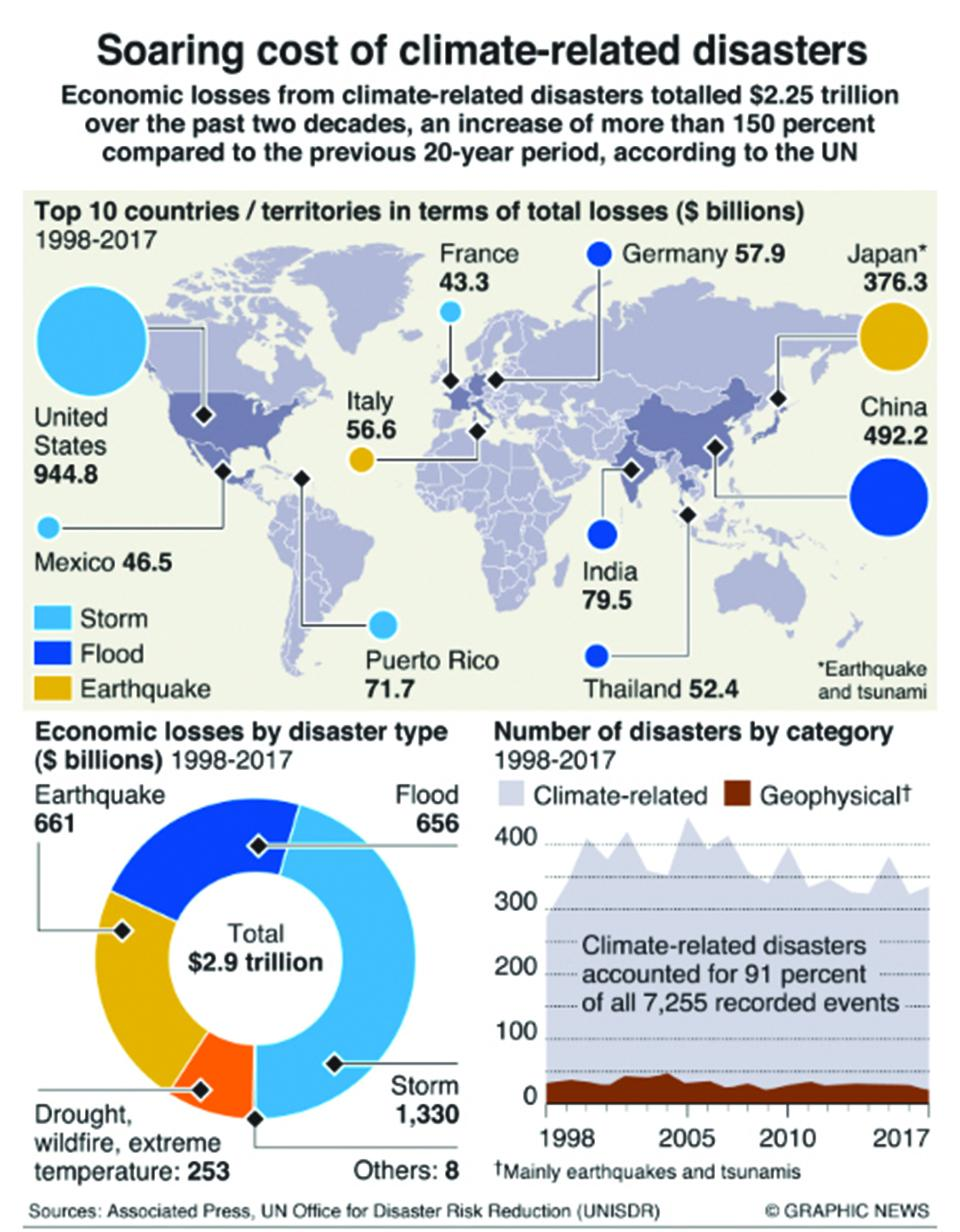Give some essential details in this illustration. The total economic loss caused by the floods between 1998 and 2017 was approximately 656 billion US dollars. Japan has suffered the highest amount of economic loss from earthquakes from 1998 to 2017. According to data compiled from 1998 to 2017, China has suffered the highest amount of economic loss due to floods. The economic loss caused by earthquakes in India between 1998 and 2017 was estimated to be approximately 79.5 billion dollars. According to data from 1998 to 2017, the United States has suffered the highest amount of economic loss from storms, making it the country that has suffered the most damage due to these natural disasters. 